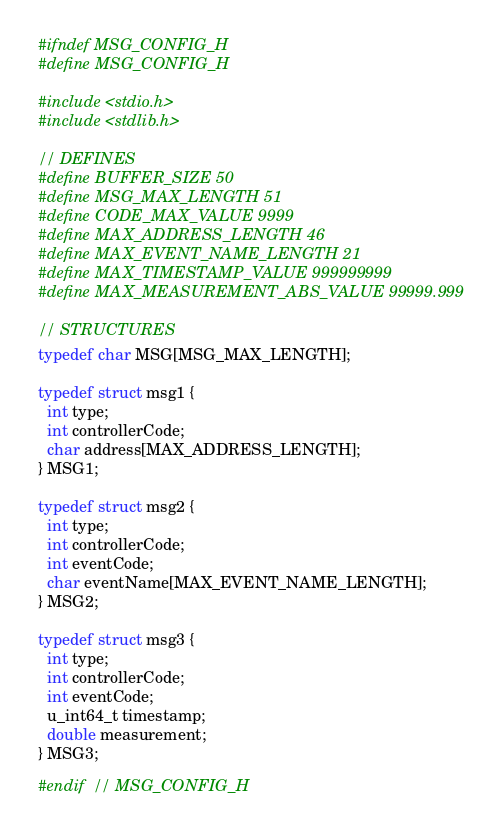Convert code to text. <code><loc_0><loc_0><loc_500><loc_500><_C_>#ifndef MSG_CONFIG_H
#define MSG_CONFIG_H

#include <stdio.h>
#include <stdlib.h>

// DEFINES
#define BUFFER_SIZE 50
#define MSG_MAX_LENGTH 51
#define CODE_MAX_VALUE 9999
#define MAX_ADDRESS_LENGTH 46
#define MAX_EVENT_NAME_LENGTH 21
#define MAX_TIMESTAMP_VALUE 999999999
#define MAX_MEASUREMENT_ABS_VALUE 99999.999

// STRUCTURES
typedef char MSG[MSG_MAX_LENGTH];

typedef struct msg1 {
  int type;
  int controllerCode;
  char address[MAX_ADDRESS_LENGTH];
} MSG1;

typedef struct msg2 {
  int type;
  int controllerCode;
  int eventCode;
  char eventName[MAX_EVENT_NAME_LENGTH];
} MSG2;

typedef struct msg3 {
  int type;
  int controllerCode;
  int eventCode;
  u_int64_t timestamp;
  double measurement;
} MSG3;

#endif  // MSG_CONFIG_H
</code> 